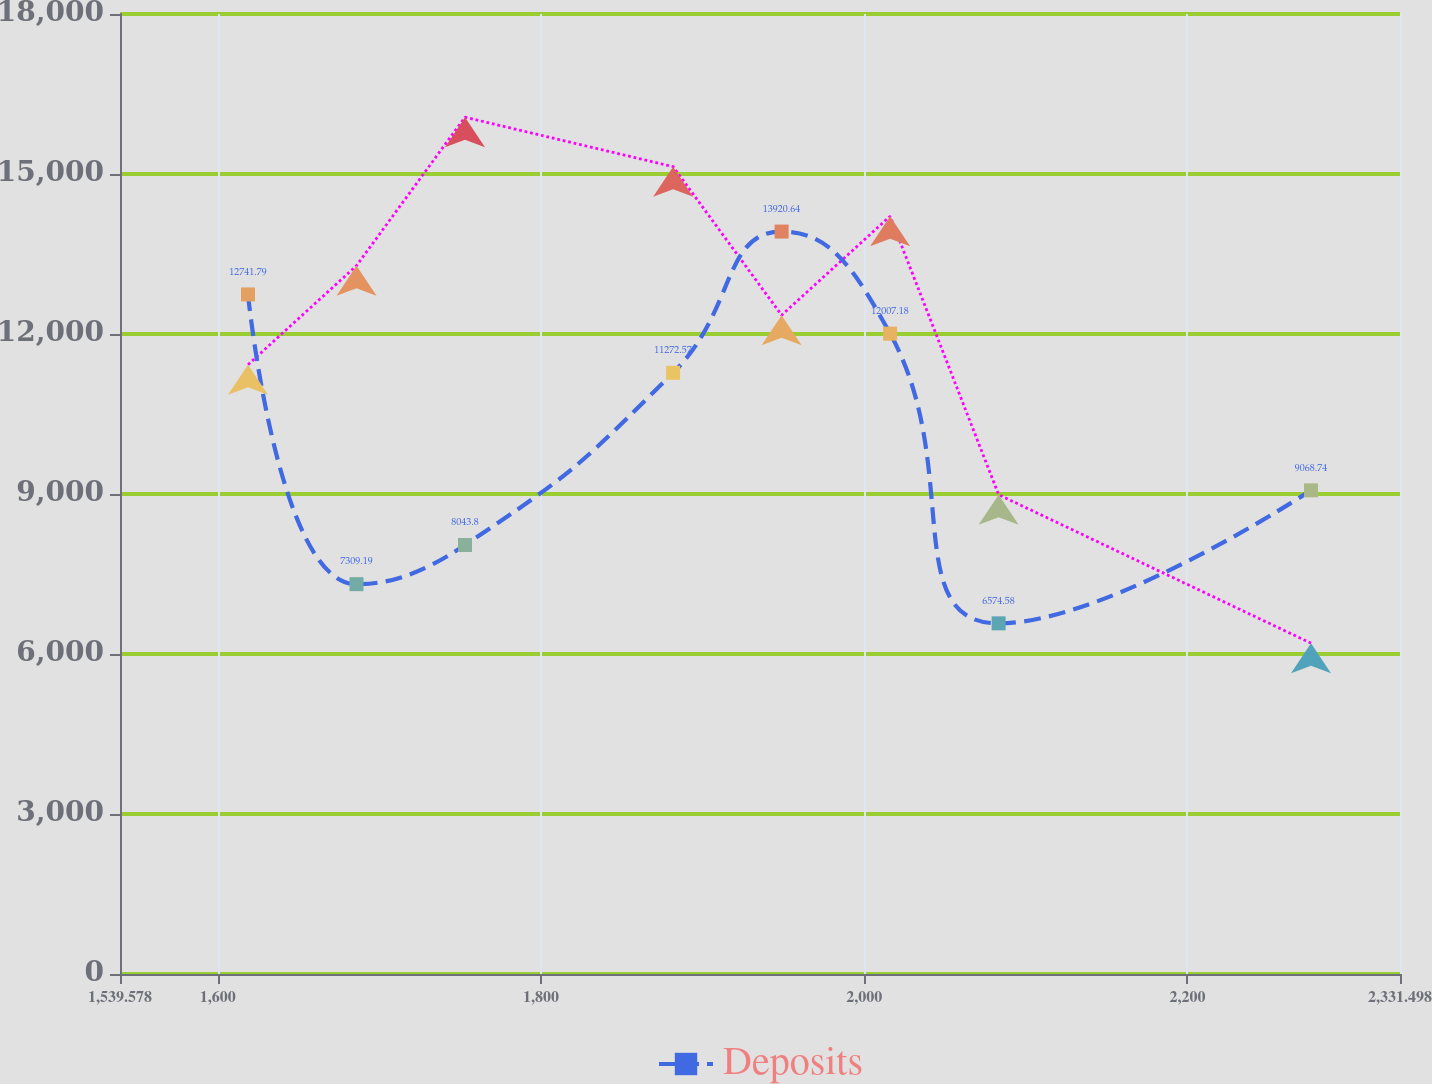<chart> <loc_0><loc_0><loc_500><loc_500><line_chart><ecel><fcel>Unnamed: 1<fcel>Deposits<nl><fcel>1618.77<fcel>11424.9<fcel>12741.8<nl><fcel>1685.9<fcel>13281<fcel>7309.19<nl><fcel>1753.03<fcel>16065.2<fcel>8043.8<nl><fcel>1881.78<fcel>15137.1<fcel>11272.6<nl><fcel>1948.91<fcel>12353<fcel>13920.6<nl><fcel>2016.04<fcel>14209.1<fcel>12007.2<nl><fcel>2083.17<fcel>8986.97<fcel>6574.58<nl><fcel>2276.43<fcel>6202.82<fcel>9068.74<nl><fcel>2343.56<fcel>7130.87<fcel>10538<nl><fcel>2410.69<fcel>8058.92<fcel>9803.35<nl></chart> 